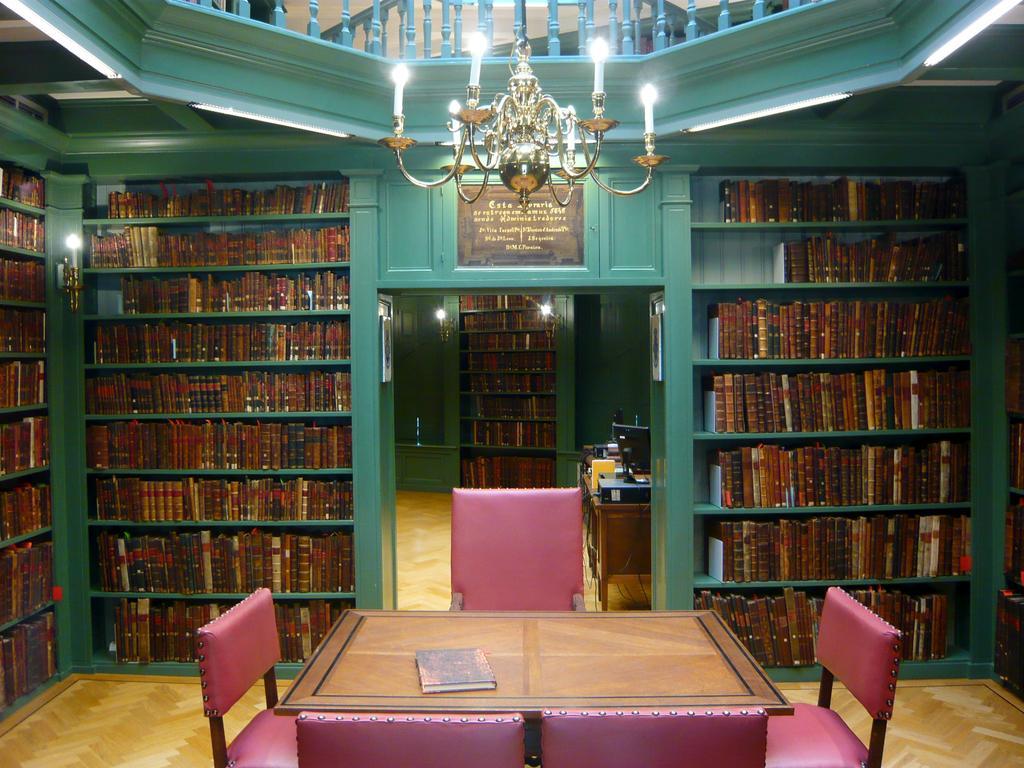In one or two sentences, can you explain what this image depicts? In this image there are shelves having books inside. In middle there is a door. Behind the door there is a table having monitor, files on it. There are few books in the shelves in the next room. There is a chandelier hanging at the top of the image. There is a table surrounded by four chairs at the bottom of the image. There is a book on the table. 